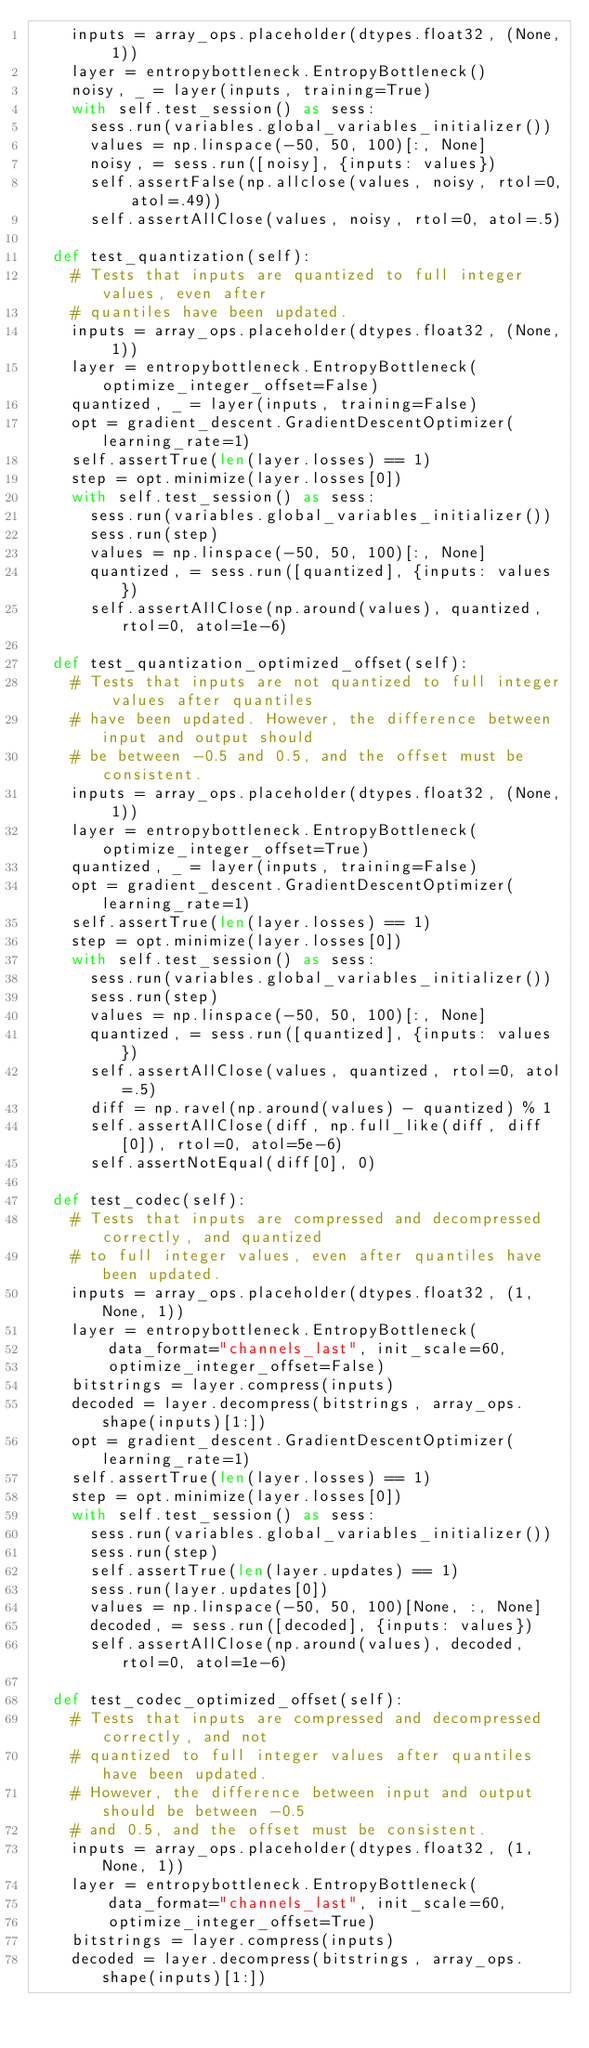<code> <loc_0><loc_0><loc_500><loc_500><_Python_>    inputs = array_ops.placeholder(dtypes.float32, (None, 1))
    layer = entropybottleneck.EntropyBottleneck()
    noisy, _ = layer(inputs, training=True)
    with self.test_session() as sess:
      sess.run(variables.global_variables_initializer())
      values = np.linspace(-50, 50, 100)[:, None]
      noisy, = sess.run([noisy], {inputs: values})
      self.assertFalse(np.allclose(values, noisy, rtol=0, atol=.49))
      self.assertAllClose(values, noisy, rtol=0, atol=.5)

  def test_quantization(self):
    # Tests that inputs are quantized to full integer values, even after
    # quantiles have been updated.
    inputs = array_ops.placeholder(dtypes.float32, (None, 1))
    layer = entropybottleneck.EntropyBottleneck(optimize_integer_offset=False)
    quantized, _ = layer(inputs, training=False)
    opt = gradient_descent.GradientDescentOptimizer(learning_rate=1)
    self.assertTrue(len(layer.losses) == 1)
    step = opt.minimize(layer.losses[0])
    with self.test_session() as sess:
      sess.run(variables.global_variables_initializer())
      sess.run(step)
      values = np.linspace(-50, 50, 100)[:, None]
      quantized, = sess.run([quantized], {inputs: values})
      self.assertAllClose(np.around(values), quantized, rtol=0, atol=1e-6)

  def test_quantization_optimized_offset(self):
    # Tests that inputs are not quantized to full integer values after quantiles
    # have been updated. However, the difference between input and output should
    # be between -0.5 and 0.5, and the offset must be consistent.
    inputs = array_ops.placeholder(dtypes.float32, (None, 1))
    layer = entropybottleneck.EntropyBottleneck(optimize_integer_offset=True)
    quantized, _ = layer(inputs, training=False)
    opt = gradient_descent.GradientDescentOptimizer(learning_rate=1)
    self.assertTrue(len(layer.losses) == 1)
    step = opt.minimize(layer.losses[0])
    with self.test_session() as sess:
      sess.run(variables.global_variables_initializer())
      sess.run(step)
      values = np.linspace(-50, 50, 100)[:, None]
      quantized, = sess.run([quantized], {inputs: values})
      self.assertAllClose(values, quantized, rtol=0, atol=.5)
      diff = np.ravel(np.around(values) - quantized) % 1
      self.assertAllClose(diff, np.full_like(diff, diff[0]), rtol=0, atol=5e-6)
      self.assertNotEqual(diff[0], 0)

  def test_codec(self):
    # Tests that inputs are compressed and decompressed correctly, and quantized
    # to full integer values, even after quantiles have been updated.
    inputs = array_ops.placeholder(dtypes.float32, (1, None, 1))
    layer = entropybottleneck.EntropyBottleneck(
        data_format="channels_last", init_scale=60,
        optimize_integer_offset=False)
    bitstrings = layer.compress(inputs)
    decoded = layer.decompress(bitstrings, array_ops.shape(inputs)[1:])
    opt = gradient_descent.GradientDescentOptimizer(learning_rate=1)
    self.assertTrue(len(layer.losses) == 1)
    step = opt.minimize(layer.losses[0])
    with self.test_session() as sess:
      sess.run(variables.global_variables_initializer())
      sess.run(step)
      self.assertTrue(len(layer.updates) == 1)
      sess.run(layer.updates[0])
      values = np.linspace(-50, 50, 100)[None, :, None]
      decoded, = sess.run([decoded], {inputs: values})
      self.assertAllClose(np.around(values), decoded, rtol=0, atol=1e-6)

  def test_codec_optimized_offset(self):
    # Tests that inputs are compressed and decompressed correctly, and not
    # quantized to full integer values after quantiles have been updated.
    # However, the difference between input and output should be between -0.5
    # and 0.5, and the offset must be consistent.
    inputs = array_ops.placeholder(dtypes.float32, (1, None, 1))
    layer = entropybottleneck.EntropyBottleneck(
        data_format="channels_last", init_scale=60,
        optimize_integer_offset=True)
    bitstrings = layer.compress(inputs)
    decoded = layer.decompress(bitstrings, array_ops.shape(inputs)[1:])</code> 